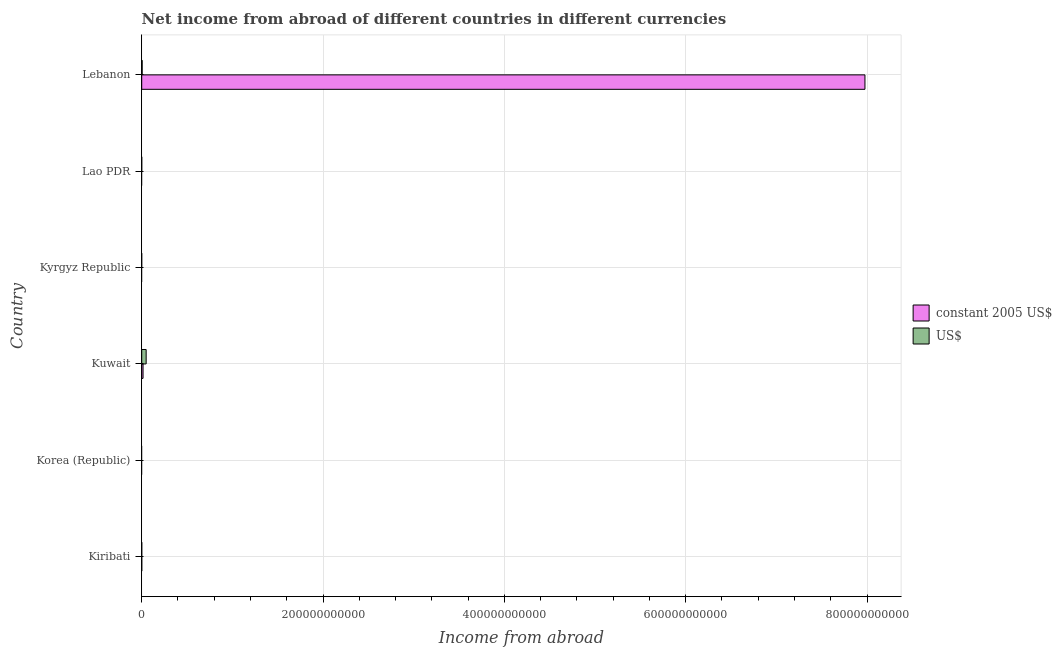Are the number of bars per tick equal to the number of legend labels?
Make the answer very short. No. How many bars are there on the 4th tick from the top?
Offer a very short reply. 2. What is the label of the 2nd group of bars from the top?
Make the answer very short. Lao PDR. In how many cases, is the number of bars for a given country not equal to the number of legend labels?
Make the answer very short. 3. What is the income from abroad in us$ in Kuwait?
Offer a very short reply. 4.88e+09. Across all countries, what is the maximum income from abroad in constant 2005 us$?
Offer a terse response. 7.98e+11. In which country was the income from abroad in us$ maximum?
Make the answer very short. Kuwait. What is the total income from abroad in us$ in the graph?
Your response must be concise. 5.41e+09. What is the difference between the income from abroad in constant 2005 us$ in Kiribati and that in Lebanon?
Keep it short and to the point. -7.98e+11. What is the difference between the income from abroad in us$ in Kuwait and the income from abroad in constant 2005 us$ in Lebanon?
Ensure brevity in your answer.  -7.93e+11. What is the average income from abroad in us$ per country?
Your answer should be very brief. 9.01e+08. What is the difference between the income from abroad in constant 2005 us$ and income from abroad in us$ in Lebanon?
Ensure brevity in your answer.  7.97e+11. In how many countries, is the income from abroad in us$ greater than 400000000000 units?
Your answer should be compact. 0. What is the ratio of the income from abroad in us$ in Kuwait to that in Lebanon?
Give a very brief answer. 9.92. What is the difference between the highest and the second highest income from abroad in us$?
Keep it short and to the point. 4.39e+09. What is the difference between the highest and the lowest income from abroad in constant 2005 us$?
Make the answer very short. 7.98e+11. Are all the bars in the graph horizontal?
Your answer should be compact. Yes. What is the difference between two consecutive major ticks on the X-axis?
Offer a terse response. 2.00e+11. Are the values on the major ticks of X-axis written in scientific E-notation?
Provide a short and direct response. No. Does the graph contain any zero values?
Your answer should be compact. Yes. Does the graph contain grids?
Make the answer very short. Yes. How many legend labels are there?
Ensure brevity in your answer.  2. What is the title of the graph?
Give a very brief answer. Net income from abroad of different countries in different currencies. Does "Non-pregnant women" appear as one of the legend labels in the graph?
Your answer should be compact. No. What is the label or title of the X-axis?
Your answer should be very brief. Income from abroad. What is the Income from abroad in constant 2005 US$ in Kiribati?
Make the answer very short. 4.56e+07. What is the Income from abroad in US$ in Kiribati?
Provide a succinct answer. 3.38e+07. What is the Income from abroad of constant 2005 US$ in Korea (Republic)?
Offer a very short reply. 0. What is the Income from abroad of US$ in Korea (Republic)?
Offer a very short reply. 0. What is the Income from abroad of constant 2005 US$ in Kuwait?
Your answer should be compact. 1.46e+09. What is the Income from abroad of US$ in Kuwait?
Your answer should be very brief. 4.88e+09. What is the Income from abroad in US$ in Kyrgyz Republic?
Ensure brevity in your answer.  0. What is the Income from abroad in constant 2005 US$ in Lebanon?
Your answer should be very brief. 7.98e+11. What is the Income from abroad in US$ in Lebanon?
Make the answer very short. 4.92e+08. Across all countries, what is the maximum Income from abroad in constant 2005 US$?
Offer a very short reply. 7.98e+11. Across all countries, what is the maximum Income from abroad in US$?
Ensure brevity in your answer.  4.88e+09. What is the total Income from abroad in constant 2005 US$ in the graph?
Give a very brief answer. 7.99e+11. What is the total Income from abroad of US$ in the graph?
Provide a short and direct response. 5.41e+09. What is the difference between the Income from abroad of constant 2005 US$ in Kiribati and that in Kuwait?
Ensure brevity in your answer.  -1.41e+09. What is the difference between the Income from abroad of US$ in Kiribati and that in Kuwait?
Keep it short and to the point. -4.85e+09. What is the difference between the Income from abroad in constant 2005 US$ in Kiribati and that in Lebanon?
Ensure brevity in your answer.  -7.98e+11. What is the difference between the Income from abroad in US$ in Kiribati and that in Lebanon?
Your answer should be very brief. -4.58e+08. What is the difference between the Income from abroad in constant 2005 US$ in Kuwait and that in Lebanon?
Provide a succinct answer. -7.96e+11. What is the difference between the Income from abroad in US$ in Kuwait and that in Lebanon?
Make the answer very short. 4.39e+09. What is the difference between the Income from abroad of constant 2005 US$ in Kiribati and the Income from abroad of US$ in Kuwait?
Give a very brief answer. -4.84e+09. What is the difference between the Income from abroad of constant 2005 US$ in Kiribati and the Income from abroad of US$ in Lebanon?
Make the answer very short. -4.46e+08. What is the difference between the Income from abroad in constant 2005 US$ in Kuwait and the Income from abroad in US$ in Lebanon?
Keep it short and to the point. 9.65e+08. What is the average Income from abroad in constant 2005 US$ per country?
Ensure brevity in your answer.  1.33e+11. What is the average Income from abroad in US$ per country?
Give a very brief answer. 9.01e+08. What is the difference between the Income from abroad of constant 2005 US$ and Income from abroad of US$ in Kiribati?
Ensure brevity in your answer.  1.18e+07. What is the difference between the Income from abroad of constant 2005 US$ and Income from abroad of US$ in Kuwait?
Provide a succinct answer. -3.43e+09. What is the difference between the Income from abroad in constant 2005 US$ and Income from abroad in US$ in Lebanon?
Your answer should be compact. 7.97e+11. What is the ratio of the Income from abroad in constant 2005 US$ in Kiribati to that in Kuwait?
Provide a succinct answer. 0.03. What is the ratio of the Income from abroad in US$ in Kiribati to that in Kuwait?
Offer a very short reply. 0.01. What is the ratio of the Income from abroad in constant 2005 US$ in Kiribati to that in Lebanon?
Your answer should be very brief. 0. What is the ratio of the Income from abroad in US$ in Kiribati to that in Lebanon?
Your answer should be compact. 0.07. What is the ratio of the Income from abroad of constant 2005 US$ in Kuwait to that in Lebanon?
Provide a succinct answer. 0. What is the ratio of the Income from abroad in US$ in Kuwait to that in Lebanon?
Provide a succinct answer. 9.92. What is the difference between the highest and the second highest Income from abroad of constant 2005 US$?
Give a very brief answer. 7.96e+11. What is the difference between the highest and the second highest Income from abroad of US$?
Ensure brevity in your answer.  4.39e+09. What is the difference between the highest and the lowest Income from abroad of constant 2005 US$?
Your answer should be compact. 7.98e+11. What is the difference between the highest and the lowest Income from abroad of US$?
Offer a very short reply. 4.88e+09. 